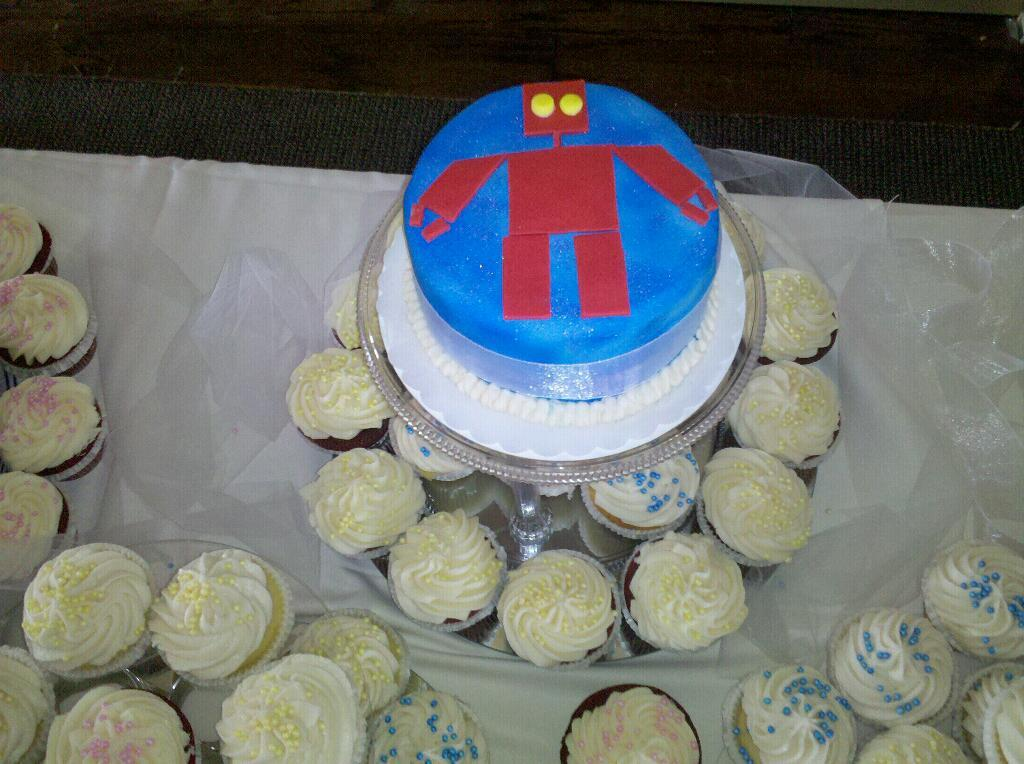What type of food can be seen in the image? There are cupcakes in the image. What else is present on the table with the cupcakes? There are jars in the image. Where are the cupcakes and jars located? The cupcakes and jars are placed on a table. What is visible at the bottom of the image? There is a carpet at the bottom of the image. Can you see the writer working on their manuscript in the image? There is no writer or manuscript present in the image; it features cupcakes, jars, a table, and a carpet. 